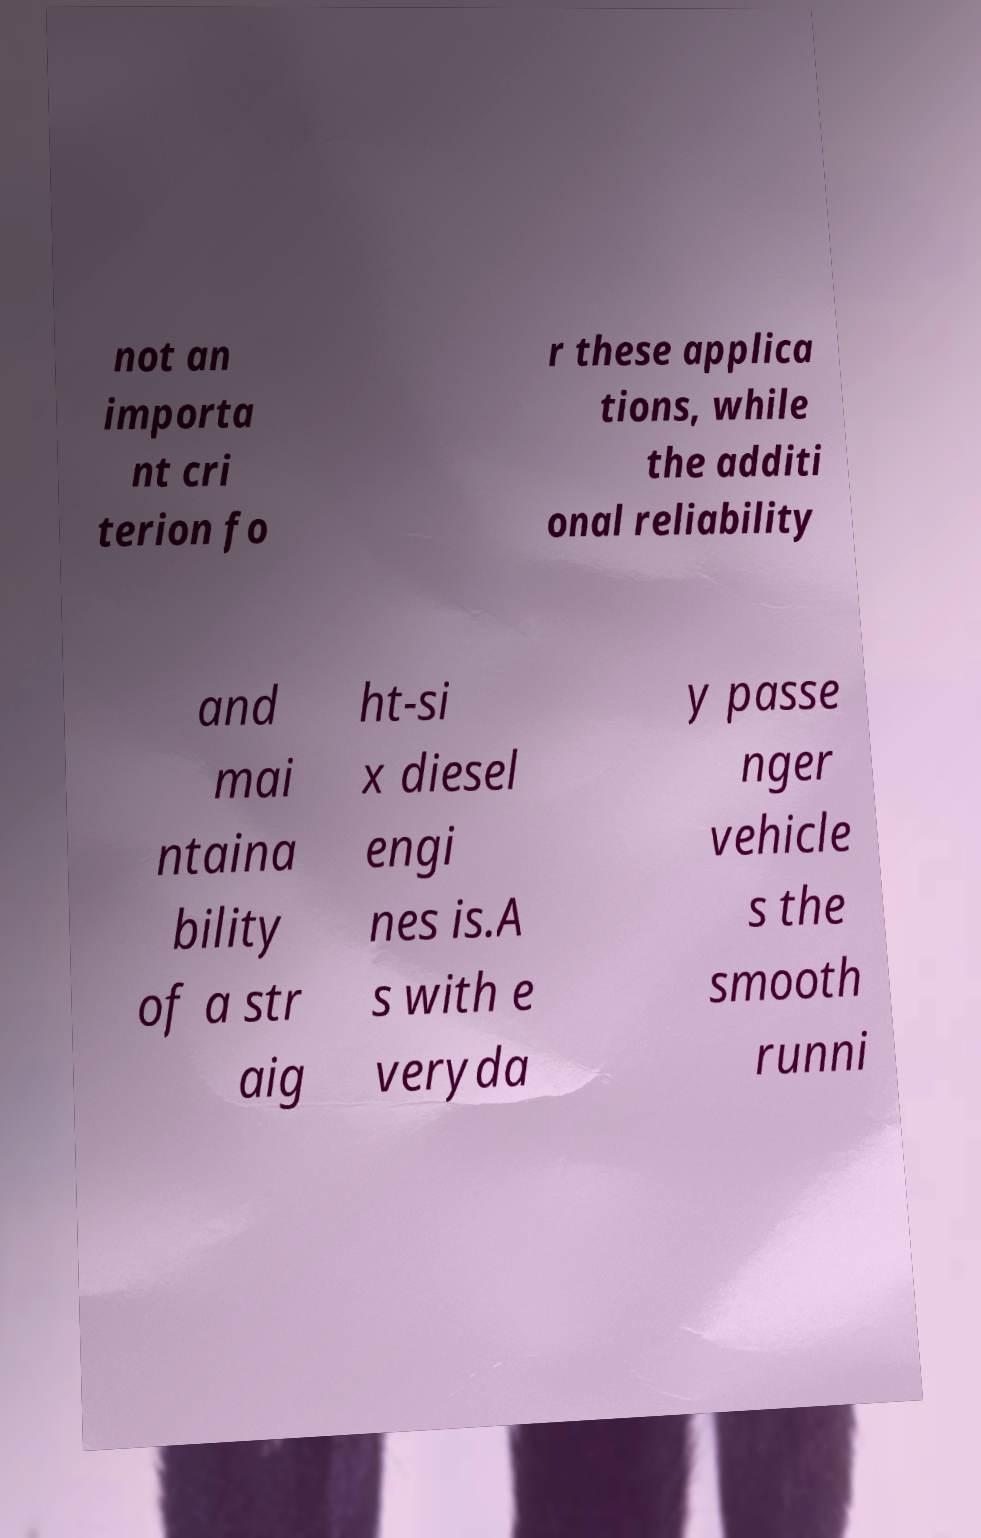Please identify and transcribe the text found in this image. not an importa nt cri terion fo r these applica tions, while the additi onal reliability and mai ntaina bility of a str aig ht-si x diesel engi nes is.A s with e veryda y passe nger vehicle s the smooth runni 